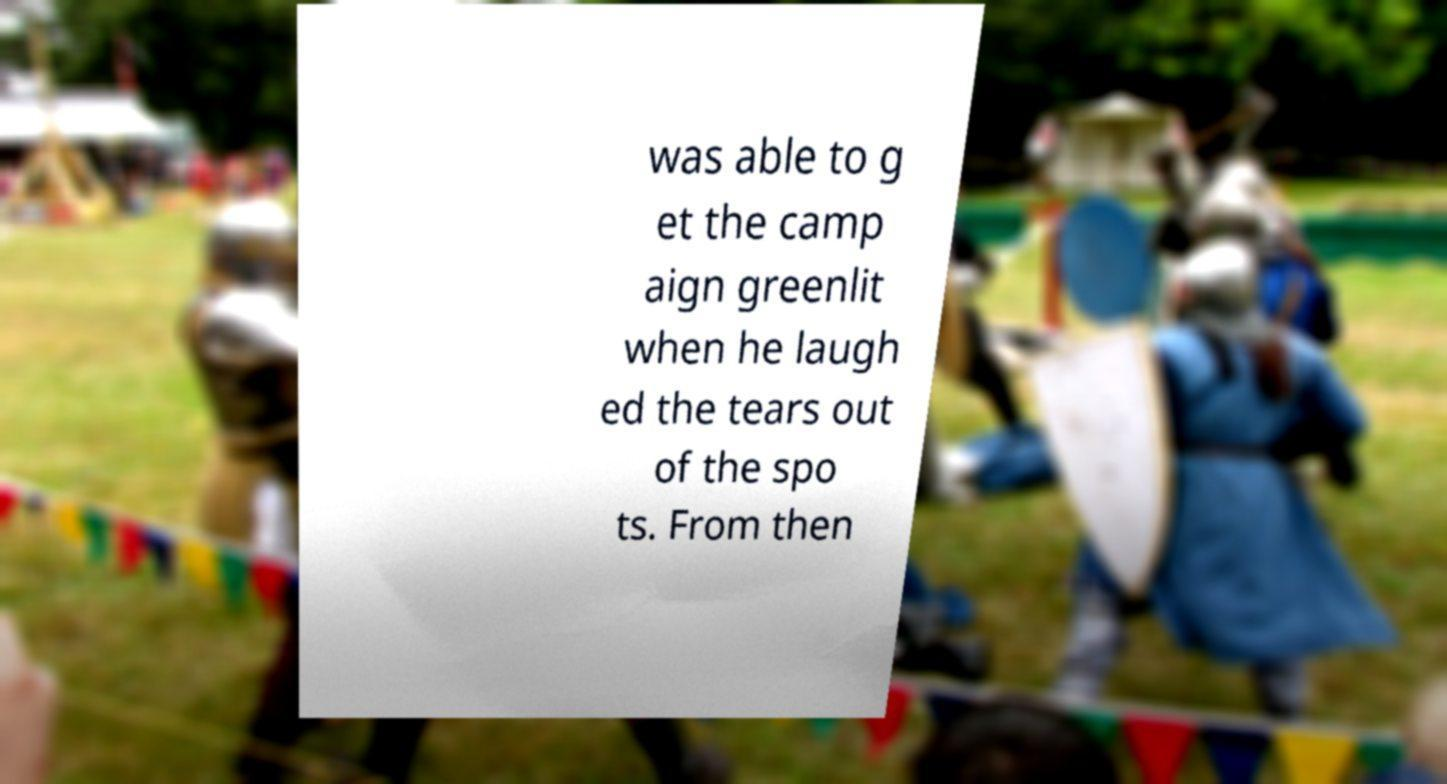Could you assist in decoding the text presented in this image and type it out clearly? was able to g et the camp aign greenlit when he laugh ed the tears out of the spo ts. From then 